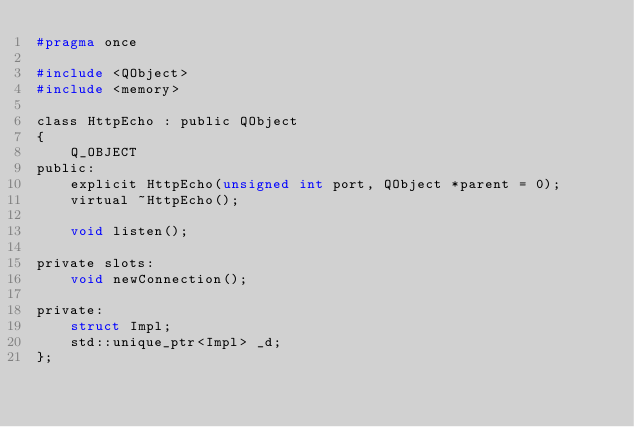<code> <loc_0><loc_0><loc_500><loc_500><_C_>#pragma once

#include <QObject>
#include <memory>

class HttpEcho : public QObject
{
    Q_OBJECT
public:
    explicit HttpEcho(unsigned int port, QObject *parent = 0);
    virtual ~HttpEcho();

    void listen();

private slots:
    void newConnection();

private:
    struct Impl;
    std::unique_ptr<Impl> _d;
};</code> 